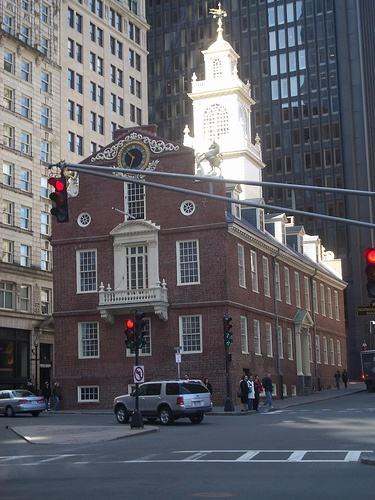Describe the objects in this image and their specific colors. I can see car in gray, black, and darkblue tones, car in gray and black tones, traffic light in gray, black, maroon, and red tones, truck in gray, black, and darkblue tones, and clock in gray and black tones in this image. 